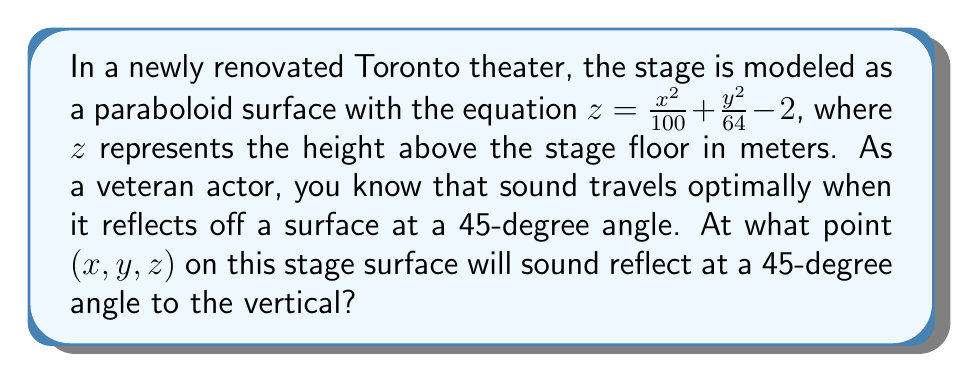Help me with this question. To solve this problem, we'll follow these steps:

1) The normal vector to the surface at any point is perpendicular to the tangent plane. We can find this using the gradient:

   $\nabla f = (\frac{\partial f}{\partial x}, \frac{\partial f}{\partial y}, \frac{\partial f}{\partial z}) = (\frac{x}{50}, \frac{y}{32}, -1)$

2) For a 45-degree angle with the vertical, the normal vector should make a 45-degree angle with the z-axis. This means the z-component of the unit normal vector should be $\frac{1}{\sqrt{2}}$.

3) Let's normalize the gradient vector:

   $\hat{n} = \frac{(\frac{x}{50}, \frac{y}{32}, -1)}{\sqrt{(\frac{x}{50})^2 + (\frac{y}{32})^2 + 1}}$

4) We want the z-component to be $-\frac{1}{\sqrt{2}}$ (negative because the normal points downward):

   $\frac{-1}{\sqrt{(\frac{x}{50})^2 + (\frac{y}{32})^2 + 1}} = -\frac{1}{\sqrt{2}}$

5) Squaring both sides:

   $\frac{1}{(\frac{x}{50})^2 + (\frac{y}{32})^2 + 1} = \frac{1}{2}$

6) Simplifying:

   $(\frac{x}{50})^2 + (\frac{y}{32})^2 = 1$

7) This is the equation of an ellipse. Due to symmetry, we can choose the point where $x = y$. Substituting:

   $(\frac{x}{50})^2 + (\frac{x}{32})^2 = 1$

8) Solving this equation:

   $x = y \approx 28.28$

9) Substituting back into the original equation:

   $z = \frac{28.28^2}{100} + \frac{28.28^2}{64} - 2 \approx 10.57$

Therefore, the point is approximately (28.28, 28.28, 10.57).
Answer: (28.28, 28.28, 10.57) 